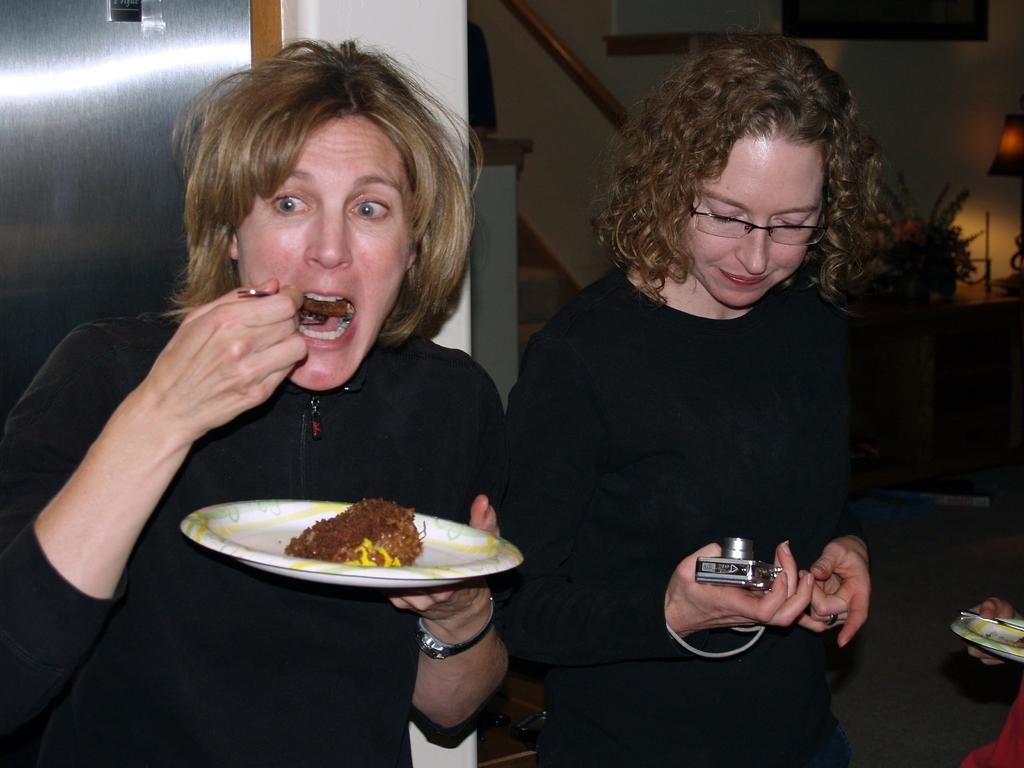How many women are present in the image? There are two women in the image. What are the women wearing? Both women are wearing black dresses. What is one of the women holding in her hand? One of the women is holding a plate in her hand. What can be seen in the background of the image? There is a wall in the background of the image. What type of health issues are the women discussing in the image? There is no indication in the image that the women are discussing any health issues. 